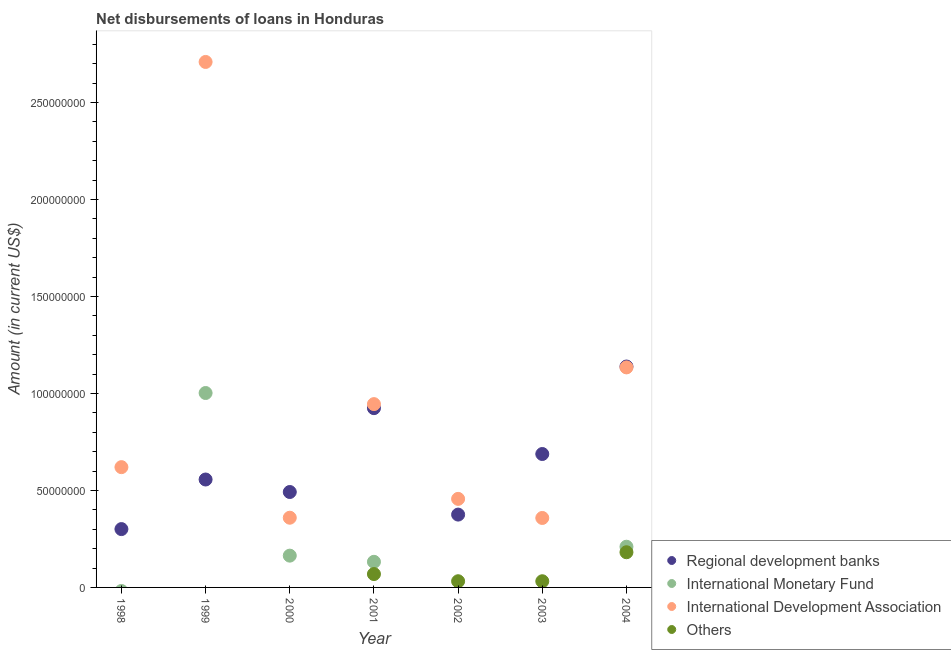Is the number of dotlines equal to the number of legend labels?
Give a very brief answer. No. What is the amount of loan disimbursed by other organisations in 2002?
Offer a very short reply. 3.20e+06. Across all years, what is the maximum amount of loan disimbursed by regional development banks?
Offer a terse response. 1.14e+08. In which year was the amount of loan disimbursed by regional development banks maximum?
Your answer should be very brief. 2004. What is the total amount of loan disimbursed by international monetary fund in the graph?
Your answer should be compact. 1.51e+08. What is the difference between the amount of loan disimbursed by international development association in 1998 and that in 2003?
Your answer should be very brief. 2.62e+07. What is the difference between the amount of loan disimbursed by international development association in 1999 and the amount of loan disimbursed by international monetary fund in 2002?
Keep it short and to the point. 2.71e+08. What is the average amount of loan disimbursed by international monetary fund per year?
Provide a succinct answer. 2.15e+07. In the year 2004, what is the difference between the amount of loan disimbursed by other organisations and amount of loan disimbursed by regional development banks?
Your answer should be very brief. -9.57e+07. In how many years, is the amount of loan disimbursed by other organisations greater than 160000000 US$?
Your answer should be compact. 0. What is the ratio of the amount of loan disimbursed by regional development banks in 1999 to that in 2003?
Provide a short and direct response. 0.81. Is the difference between the amount of loan disimbursed by other organisations in 2003 and 2004 greater than the difference between the amount of loan disimbursed by regional development banks in 2003 and 2004?
Provide a succinct answer. Yes. What is the difference between the highest and the second highest amount of loan disimbursed by international development association?
Make the answer very short. 1.57e+08. What is the difference between the highest and the lowest amount of loan disimbursed by other organisations?
Make the answer very short. 1.81e+07. In how many years, is the amount of loan disimbursed by other organisations greater than the average amount of loan disimbursed by other organisations taken over all years?
Ensure brevity in your answer.  2. Does the amount of loan disimbursed by other organisations monotonically increase over the years?
Give a very brief answer. No. Is the amount of loan disimbursed by other organisations strictly less than the amount of loan disimbursed by international development association over the years?
Your answer should be compact. Yes. How many dotlines are there?
Your answer should be very brief. 4. How many legend labels are there?
Make the answer very short. 4. What is the title of the graph?
Ensure brevity in your answer.  Net disbursements of loans in Honduras. Does "Japan" appear as one of the legend labels in the graph?
Make the answer very short. No. What is the label or title of the X-axis?
Offer a very short reply. Year. What is the label or title of the Y-axis?
Your answer should be compact. Amount (in current US$). What is the Amount (in current US$) in Regional development banks in 1998?
Ensure brevity in your answer.  3.01e+07. What is the Amount (in current US$) in International Development Association in 1998?
Ensure brevity in your answer.  6.20e+07. What is the Amount (in current US$) in Regional development banks in 1999?
Provide a succinct answer. 5.56e+07. What is the Amount (in current US$) in International Monetary Fund in 1999?
Your answer should be compact. 1.00e+08. What is the Amount (in current US$) in International Development Association in 1999?
Your answer should be compact. 2.71e+08. What is the Amount (in current US$) in Others in 1999?
Provide a short and direct response. 0. What is the Amount (in current US$) of Regional development banks in 2000?
Make the answer very short. 4.92e+07. What is the Amount (in current US$) of International Monetary Fund in 2000?
Provide a succinct answer. 1.64e+07. What is the Amount (in current US$) of International Development Association in 2000?
Offer a terse response. 3.59e+07. What is the Amount (in current US$) in Others in 2000?
Provide a short and direct response. 0. What is the Amount (in current US$) in Regional development banks in 2001?
Provide a succinct answer. 9.24e+07. What is the Amount (in current US$) of International Monetary Fund in 2001?
Your answer should be very brief. 1.32e+07. What is the Amount (in current US$) in International Development Association in 2001?
Your response must be concise. 9.45e+07. What is the Amount (in current US$) in Others in 2001?
Your response must be concise. 6.89e+06. What is the Amount (in current US$) of Regional development banks in 2002?
Offer a very short reply. 3.75e+07. What is the Amount (in current US$) in International Development Association in 2002?
Keep it short and to the point. 4.56e+07. What is the Amount (in current US$) in Others in 2002?
Offer a terse response. 3.20e+06. What is the Amount (in current US$) of Regional development banks in 2003?
Ensure brevity in your answer.  6.88e+07. What is the Amount (in current US$) in International Development Association in 2003?
Make the answer very short. 3.58e+07. What is the Amount (in current US$) in Others in 2003?
Your response must be concise. 3.18e+06. What is the Amount (in current US$) of Regional development banks in 2004?
Your answer should be compact. 1.14e+08. What is the Amount (in current US$) in International Monetary Fund in 2004?
Your answer should be very brief. 2.10e+07. What is the Amount (in current US$) in International Development Association in 2004?
Offer a terse response. 1.13e+08. What is the Amount (in current US$) in Others in 2004?
Give a very brief answer. 1.81e+07. Across all years, what is the maximum Amount (in current US$) in Regional development banks?
Give a very brief answer. 1.14e+08. Across all years, what is the maximum Amount (in current US$) of International Monetary Fund?
Your answer should be very brief. 1.00e+08. Across all years, what is the maximum Amount (in current US$) of International Development Association?
Your answer should be compact. 2.71e+08. Across all years, what is the maximum Amount (in current US$) of Others?
Offer a very short reply. 1.81e+07. Across all years, what is the minimum Amount (in current US$) in Regional development banks?
Give a very brief answer. 3.01e+07. Across all years, what is the minimum Amount (in current US$) in International Monetary Fund?
Offer a very short reply. 0. Across all years, what is the minimum Amount (in current US$) of International Development Association?
Offer a terse response. 3.58e+07. Across all years, what is the minimum Amount (in current US$) of Others?
Keep it short and to the point. 0. What is the total Amount (in current US$) of Regional development banks in the graph?
Your response must be concise. 4.47e+08. What is the total Amount (in current US$) in International Monetary Fund in the graph?
Make the answer very short. 1.51e+08. What is the total Amount (in current US$) in International Development Association in the graph?
Your answer should be very brief. 6.58e+08. What is the total Amount (in current US$) of Others in the graph?
Provide a short and direct response. 3.14e+07. What is the difference between the Amount (in current US$) of Regional development banks in 1998 and that in 1999?
Give a very brief answer. -2.56e+07. What is the difference between the Amount (in current US$) of International Development Association in 1998 and that in 1999?
Provide a succinct answer. -2.09e+08. What is the difference between the Amount (in current US$) in Regional development banks in 1998 and that in 2000?
Offer a terse response. -1.91e+07. What is the difference between the Amount (in current US$) in International Development Association in 1998 and that in 2000?
Provide a short and direct response. 2.61e+07. What is the difference between the Amount (in current US$) of Regional development banks in 1998 and that in 2001?
Ensure brevity in your answer.  -6.23e+07. What is the difference between the Amount (in current US$) in International Development Association in 1998 and that in 2001?
Keep it short and to the point. -3.25e+07. What is the difference between the Amount (in current US$) in Regional development banks in 1998 and that in 2002?
Provide a succinct answer. -7.47e+06. What is the difference between the Amount (in current US$) in International Development Association in 1998 and that in 2002?
Offer a terse response. 1.64e+07. What is the difference between the Amount (in current US$) of Regional development banks in 1998 and that in 2003?
Give a very brief answer. -3.87e+07. What is the difference between the Amount (in current US$) of International Development Association in 1998 and that in 2003?
Your answer should be very brief. 2.62e+07. What is the difference between the Amount (in current US$) in Regional development banks in 1998 and that in 2004?
Offer a terse response. -8.38e+07. What is the difference between the Amount (in current US$) in International Development Association in 1998 and that in 2004?
Provide a succinct answer. -5.14e+07. What is the difference between the Amount (in current US$) of Regional development banks in 1999 and that in 2000?
Ensure brevity in your answer.  6.44e+06. What is the difference between the Amount (in current US$) of International Monetary Fund in 1999 and that in 2000?
Provide a short and direct response. 8.38e+07. What is the difference between the Amount (in current US$) in International Development Association in 1999 and that in 2000?
Provide a short and direct response. 2.35e+08. What is the difference between the Amount (in current US$) in Regional development banks in 1999 and that in 2001?
Provide a short and direct response. -3.68e+07. What is the difference between the Amount (in current US$) in International Monetary Fund in 1999 and that in 2001?
Provide a short and direct response. 8.70e+07. What is the difference between the Amount (in current US$) of International Development Association in 1999 and that in 2001?
Your answer should be compact. 1.76e+08. What is the difference between the Amount (in current US$) in Regional development banks in 1999 and that in 2002?
Keep it short and to the point. 1.81e+07. What is the difference between the Amount (in current US$) of International Development Association in 1999 and that in 2002?
Provide a short and direct response. 2.25e+08. What is the difference between the Amount (in current US$) in Regional development banks in 1999 and that in 2003?
Provide a succinct answer. -1.31e+07. What is the difference between the Amount (in current US$) of International Development Association in 1999 and that in 2003?
Your response must be concise. 2.35e+08. What is the difference between the Amount (in current US$) in Regional development banks in 1999 and that in 2004?
Provide a short and direct response. -5.82e+07. What is the difference between the Amount (in current US$) in International Monetary Fund in 1999 and that in 2004?
Your answer should be compact. 7.92e+07. What is the difference between the Amount (in current US$) of International Development Association in 1999 and that in 2004?
Offer a terse response. 1.57e+08. What is the difference between the Amount (in current US$) in Regional development banks in 2000 and that in 2001?
Give a very brief answer. -4.32e+07. What is the difference between the Amount (in current US$) in International Monetary Fund in 2000 and that in 2001?
Your answer should be very brief. 3.18e+06. What is the difference between the Amount (in current US$) in International Development Association in 2000 and that in 2001?
Provide a succinct answer. -5.86e+07. What is the difference between the Amount (in current US$) in Regional development banks in 2000 and that in 2002?
Offer a very short reply. 1.16e+07. What is the difference between the Amount (in current US$) in International Development Association in 2000 and that in 2002?
Give a very brief answer. -9.72e+06. What is the difference between the Amount (in current US$) of Regional development banks in 2000 and that in 2003?
Provide a succinct answer. -1.96e+07. What is the difference between the Amount (in current US$) of International Development Association in 2000 and that in 2003?
Ensure brevity in your answer.  1.26e+05. What is the difference between the Amount (in current US$) of Regional development banks in 2000 and that in 2004?
Provide a succinct answer. -6.47e+07. What is the difference between the Amount (in current US$) in International Monetary Fund in 2000 and that in 2004?
Make the answer very short. -4.60e+06. What is the difference between the Amount (in current US$) in International Development Association in 2000 and that in 2004?
Give a very brief answer. -7.75e+07. What is the difference between the Amount (in current US$) of Regional development banks in 2001 and that in 2002?
Make the answer very short. 5.49e+07. What is the difference between the Amount (in current US$) in International Development Association in 2001 and that in 2002?
Your answer should be very brief. 4.88e+07. What is the difference between the Amount (in current US$) in Others in 2001 and that in 2002?
Offer a very short reply. 3.69e+06. What is the difference between the Amount (in current US$) of Regional development banks in 2001 and that in 2003?
Provide a succinct answer. 2.36e+07. What is the difference between the Amount (in current US$) of International Development Association in 2001 and that in 2003?
Offer a very short reply. 5.87e+07. What is the difference between the Amount (in current US$) in Others in 2001 and that in 2003?
Keep it short and to the point. 3.70e+06. What is the difference between the Amount (in current US$) in Regional development banks in 2001 and that in 2004?
Your answer should be compact. -2.15e+07. What is the difference between the Amount (in current US$) in International Monetary Fund in 2001 and that in 2004?
Offer a terse response. -7.78e+06. What is the difference between the Amount (in current US$) of International Development Association in 2001 and that in 2004?
Ensure brevity in your answer.  -1.89e+07. What is the difference between the Amount (in current US$) of Others in 2001 and that in 2004?
Provide a succinct answer. -1.12e+07. What is the difference between the Amount (in current US$) in Regional development banks in 2002 and that in 2003?
Ensure brevity in your answer.  -3.12e+07. What is the difference between the Amount (in current US$) in International Development Association in 2002 and that in 2003?
Ensure brevity in your answer.  9.84e+06. What is the difference between the Amount (in current US$) in Others in 2002 and that in 2003?
Offer a very short reply. 1.20e+04. What is the difference between the Amount (in current US$) in Regional development banks in 2002 and that in 2004?
Provide a short and direct response. -7.63e+07. What is the difference between the Amount (in current US$) in International Development Association in 2002 and that in 2004?
Offer a very short reply. -6.78e+07. What is the difference between the Amount (in current US$) of Others in 2002 and that in 2004?
Your answer should be compact. -1.49e+07. What is the difference between the Amount (in current US$) of Regional development banks in 2003 and that in 2004?
Provide a short and direct response. -4.51e+07. What is the difference between the Amount (in current US$) of International Development Association in 2003 and that in 2004?
Offer a very short reply. -7.76e+07. What is the difference between the Amount (in current US$) in Others in 2003 and that in 2004?
Make the answer very short. -1.49e+07. What is the difference between the Amount (in current US$) in Regional development banks in 1998 and the Amount (in current US$) in International Monetary Fund in 1999?
Your answer should be very brief. -7.01e+07. What is the difference between the Amount (in current US$) in Regional development banks in 1998 and the Amount (in current US$) in International Development Association in 1999?
Your answer should be very brief. -2.41e+08. What is the difference between the Amount (in current US$) of Regional development banks in 1998 and the Amount (in current US$) of International Monetary Fund in 2000?
Make the answer very short. 1.37e+07. What is the difference between the Amount (in current US$) in Regional development banks in 1998 and the Amount (in current US$) in International Development Association in 2000?
Your answer should be very brief. -5.86e+06. What is the difference between the Amount (in current US$) in Regional development banks in 1998 and the Amount (in current US$) in International Monetary Fund in 2001?
Ensure brevity in your answer.  1.69e+07. What is the difference between the Amount (in current US$) in Regional development banks in 1998 and the Amount (in current US$) in International Development Association in 2001?
Your answer should be very brief. -6.44e+07. What is the difference between the Amount (in current US$) in Regional development banks in 1998 and the Amount (in current US$) in Others in 2001?
Keep it short and to the point. 2.32e+07. What is the difference between the Amount (in current US$) in International Development Association in 1998 and the Amount (in current US$) in Others in 2001?
Make the answer very short. 5.51e+07. What is the difference between the Amount (in current US$) in Regional development banks in 1998 and the Amount (in current US$) in International Development Association in 2002?
Your response must be concise. -1.56e+07. What is the difference between the Amount (in current US$) in Regional development banks in 1998 and the Amount (in current US$) in Others in 2002?
Ensure brevity in your answer.  2.69e+07. What is the difference between the Amount (in current US$) in International Development Association in 1998 and the Amount (in current US$) in Others in 2002?
Provide a short and direct response. 5.88e+07. What is the difference between the Amount (in current US$) in Regional development banks in 1998 and the Amount (in current US$) in International Development Association in 2003?
Keep it short and to the point. -5.73e+06. What is the difference between the Amount (in current US$) in Regional development banks in 1998 and the Amount (in current US$) in Others in 2003?
Give a very brief answer. 2.69e+07. What is the difference between the Amount (in current US$) in International Development Association in 1998 and the Amount (in current US$) in Others in 2003?
Keep it short and to the point. 5.88e+07. What is the difference between the Amount (in current US$) in Regional development banks in 1998 and the Amount (in current US$) in International Monetary Fund in 2004?
Your answer should be very brief. 9.09e+06. What is the difference between the Amount (in current US$) in Regional development banks in 1998 and the Amount (in current US$) in International Development Association in 2004?
Provide a succinct answer. -8.33e+07. What is the difference between the Amount (in current US$) of Regional development banks in 1998 and the Amount (in current US$) of Others in 2004?
Give a very brief answer. 1.19e+07. What is the difference between the Amount (in current US$) in International Development Association in 1998 and the Amount (in current US$) in Others in 2004?
Offer a terse response. 4.39e+07. What is the difference between the Amount (in current US$) of Regional development banks in 1999 and the Amount (in current US$) of International Monetary Fund in 2000?
Give a very brief answer. 3.92e+07. What is the difference between the Amount (in current US$) in Regional development banks in 1999 and the Amount (in current US$) in International Development Association in 2000?
Ensure brevity in your answer.  1.97e+07. What is the difference between the Amount (in current US$) of International Monetary Fund in 1999 and the Amount (in current US$) of International Development Association in 2000?
Keep it short and to the point. 6.43e+07. What is the difference between the Amount (in current US$) in Regional development banks in 1999 and the Amount (in current US$) in International Monetary Fund in 2001?
Provide a succinct answer. 4.24e+07. What is the difference between the Amount (in current US$) in Regional development banks in 1999 and the Amount (in current US$) in International Development Association in 2001?
Your response must be concise. -3.89e+07. What is the difference between the Amount (in current US$) of Regional development banks in 1999 and the Amount (in current US$) of Others in 2001?
Make the answer very short. 4.87e+07. What is the difference between the Amount (in current US$) in International Monetary Fund in 1999 and the Amount (in current US$) in International Development Association in 2001?
Keep it short and to the point. 5.72e+06. What is the difference between the Amount (in current US$) in International Monetary Fund in 1999 and the Amount (in current US$) in Others in 2001?
Your answer should be very brief. 9.33e+07. What is the difference between the Amount (in current US$) in International Development Association in 1999 and the Amount (in current US$) in Others in 2001?
Provide a short and direct response. 2.64e+08. What is the difference between the Amount (in current US$) in Regional development banks in 1999 and the Amount (in current US$) in International Development Association in 2002?
Give a very brief answer. 9.98e+06. What is the difference between the Amount (in current US$) of Regional development banks in 1999 and the Amount (in current US$) of Others in 2002?
Your answer should be compact. 5.24e+07. What is the difference between the Amount (in current US$) in International Monetary Fund in 1999 and the Amount (in current US$) in International Development Association in 2002?
Offer a very short reply. 5.46e+07. What is the difference between the Amount (in current US$) in International Monetary Fund in 1999 and the Amount (in current US$) in Others in 2002?
Make the answer very short. 9.70e+07. What is the difference between the Amount (in current US$) in International Development Association in 1999 and the Amount (in current US$) in Others in 2002?
Provide a succinct answer. 2.68e+08. What is the difference between the Amount (in current US$) of Regional development banks in 1999 and the Amount (in current US$) of International Development Association in 2003?
Provide a short and direct response. 1.98e+07. What is the difference between the Amount (in current US$) of Regional development banks in 1999 and the Amount (in current US$) of Others in 2003?
Your answer should be compact. 5.24e+07. What is the difference between the Amount (in current US$) in International Monetary Fund in 1999 and the Amount (in current US$) in International Development Association in 2003?
Give a very brief answer. 6.44e+07. What is the difference between the Amount (in current US$) of International Monetary Fund in 1999 and the Amount (in current US$) of Others in 2003?
Give a very brief answer. 9.70e+07. What is the difference between the Amount (in current US$) in International Development Association in 1999 and the Amount (in current US$) in Others in 2003?
Provide a short and direct response. 2.68e+08. What is the difference between the Amount (in current US$) in Regional development banks in 1999 and the Amount (in current US$) in International Monetary Fund in 2004?
Your answer should be very brief. 3.46e+07. What is the difference between the Amount (in current US$) in Regional development banks in 1999 and the Amount (in current US$) in International Development Association in 2004?
Make the answer very short. -5.78e+07. What is the difference between the Amount (in current US$) in Regional development banks in 1999 and the Amount (in current US$) in Others in 2004?
Make the answer very short. 3.75e+07. What is the difference between the Amount (in current US$) in International Monetary Fund in 1999 and the Amount (in current US$) in International Development Association in 2004?
Give a very brief answer. -1.32e+07. What is the difference between the Amount (in current US$) of International Monetary Fund in 1999 and the Amount (in current US$) of Others in 2004?
Give a very brief answer. 8.21e+07. What is the difference between the Amount (in current US$) of International Development Association in 1999 and the Amount (in current US$) of Others in 2004?
Your response must be concise. 2.53e+08. What is the difference between the Amount (in current US$) of Regional development banks in 2000 and the Amount (in current US$) of International Monetary Fund in 2001?
Your response must be concise. 3.60e+07. What is the difference between the Amount (in current US$) in Regional development banks in 2000 and the Amount (in current US$) in International Development Association in 2001?
Offer a very short reply. -4.53e+07. What is the difference between the Amount (in current US$) of Regional development banks in 2000 and the Amount (in current US$) of Others in 2001?
Provide a succinct answer. 4.23e+07. What is the difference between the Amount (in current US$) of International Monetary Fund in 2000 and the Amount (in current US$) of International Development Association in 2001?
Your answer should be very brief. -7.81e+07. What is the difference between the Amount (in current US$) of International Monetary Fund in 2000 and the Amount (in current US$) of Others in 2001?
Provide a short and direct response. 9.49e+06. What is the difference between the Amount (in current US$) in International Development Association in 2000 and the Amount (in current US$) in Others in 2001?
Your answer should be very brief. 2.90e+07. What is the difference between the Amount (in current US$) in Regional development banks in 2000 and the Amount (in current US$) in International Development Association in 2002?
Provide a short and direct response. 3.54e+06. What is the difference between the Amount (in current US$) of Regional development banks in 2000 and the Amount (in current US$) of Others in 2002?
Your response must be concise. 4.60e+07. What is the difference between the Amount (in current US$) of International Monetary Fund in 2000 and the Amount (in current US$) of International Development Association in 2002?
Give a very brief answer. -2.93e+07. What is the difference between the Amount (in current US$) in International Monetary Fund in 2000 and the Amount (in current US$) in Others in 2002?
Your response must be concise. 1.32e+07. What is the difference between the Amount (in current US$) of International Development Association in 2000 and the Amount (in current US$) of Others in 2002?
Offer a terse response. 3.27e+07. What is the difference between the Amount (in current US$) in Regional development banks in 2000 and the Amount (in current US$) in International Development Association in 2003?
Provide a succinct answer. 1.34e+07. What is the difference between the Amount (in current US$) of Regional development banks in 2000 and the Amount (in current US$) of Others in 2003?
Your answer should be very brief. 4.60e+07. What is the difference between the Amount (in current US$) of International Monetary Fund in 2000 and the Amount (in current US$) of International Development Association in 2003?
Provide a succinct answer. -1.94e+07. What is the difference between the Amount (in current US$) of International Monetary Fund in 2000 and the Amount (in current US$) of Others in 2003?
Ensure brevity in your answer.  1.32e+07. What is the difference between the Amount (in current US$) in International Development Association in 2000 and the Amount (in current US$) in Others in 2003?
Your answer should be very brief. 3.27e+07. What is the difference between the Amount (in current US$) in Regional development banks in 2000 and the Amount (in current US$) in International Monetary Fund in 2004?
Your answer should be compact. 2.82e+07. What is the difference between the Amount (in current US$) in Regional development banks in 2000 and the Amount (in current US$) in International Development Association in 2004?
Make the answer very short. -6.42e+07. What is the difference between the Amount (in current US$) of Regional development banks in 2000 and the Amount (in current US$) of Others in 2004?
Your answer should be very brief. 3.11e+07. What is the difference between the Amount (in current US$) in International Monetary Fund in 2000 and the Amount (in current US$) in International Development Association in 2004?
Provide a short and direct response. -9.70e+07. What is the difference between the Amount (in current US$) of International Monetary Fund in 2000 and the Amount (in current US$) of Others in 2004?
Make the answer very short. -1.75e+06. What is the difference between the Amount (in current US$) of International Development Association in 2000 and the Amount (in current US$) of Others in 2004?
Make the answer very short. 1.78e+07. What is the difference between the Amount (in current US$) of Regional development banks in 2001 and the Amount (in current US$) of International Development Association in 2002?
Provide a short and direct response. 4.68e+07. What is the difference between the Amount (in current US$) in Regional development banks in 2001 and the Amount (in current US$) in Others in 2002?
Keep it short and to the point. 8.92e+07. What is the difference between the Amount (in current US$) of International Monetary Fund in 2001 and the Amount (in current US$) of International Development Association in 2002?
Make the answer very short. -3.24e+07. What is the difference between the Amount (in current US$) in International Monetary Fund in 2001 and the Amount (in current US$) in Others in 2002?
Offer a terse response. 1.00e+07. What is the difference between the Amount (in current US$) of International Development Association in 2001 and the Amount (in current US$) of Others in 2002?
Your answer should be compact. 9.13e+07. What is the difference between the Amount (in current US$) of Regional development banks in 2001 and the Amount (in current US$) of International Development Association in 2003?
Provide a succinct answer. 5.66e+07. What is the difference between the Amount (in current US$) of Regional development banks in 2001 and the Amount (in current US$) of Others in 2003?
Your response must be concise. 8.92e+07. What is the difference between the Amount (in current US$) of International Monetary Fund in 2001 and the Amount (in current US$) of International Development Association in 2003?
Offer a very short reply. -2.26e+07. What is the difference between the Amount (in current US$) in International Monetary Fund in 2001 and the Amount (in current US$) in Others in 2003?
Keep it short and to the point. 1.00e+07. What is the difference between the Amount (in current US$) in International Development Association in 2001 and the Amount (in current US$) in Others in 2003?
Provide a succinct answer. 9.13e+07. What is the difference between the Amount (in current US$) of Regional development banks in 2001 and the Amount (in current US$) of International Monetary Fund in 2004?
Your answer should be compact. 7.14e+07. What is the difference between the Amount (in current US$) of Regional development banks in 2001 and the Amount (in current US$) of International Development Association in 2004?
Offer a very short reply. -2.10e+07. What is the difference between the Amount (in current US$) in Regional development banks in 2001 and the Amount (in current US$) in Others in 2004?
Your response must be concise. 7.43e+07. What is the difference between the Amount (in current US$) in International Monetary Fund in 2001 and the Amount (in current US$) in International Development Association in 2004?
Your answer should be very brief. -1.00e+08. What is the difference between the Amount (in current US$) in International Monetary Fund in 2001 and the Amount (in current US$) in Others in 2004?
Ensure brevity in your answer.  -4.94e+06. What is the difference between the Amount (in current US$) in International Development Association in 2001 and the Amount (in current US$) in Others in 2004?
Provide a short and direct response. 7.64e+07. What is the difference between the Amount (in current US$) in Regional development banks in 2002 and the Amount (in current US$) in International Development Association in 2003?
Your answer should be very brief. 1.74e+06. What is the difference between the Amount (in current US$) in Regional development banks in 2002 and the Amount (in current US$) in Others in 2003?
Offer a terse response. 3.44e+07. What is the difference between the Amount (in current US$) of International Development Association in 2002 and the Amount (in current US$) of Others in 2003?
Provide a succinct answer. 4.25e+07. What is the difference between the Amount (in current US$) in Regional development banks in 2002 and the Amount (in current US$) in International Monetary Fund in 2004?
Provide a succinct answer. 1.66e+07. What is the difference between the Amount (in current US$) of Regional development banks in 2002 and the Amount (in current US$) of International Development Association in 2004?
Give a very brief answer. -7.59e+07. What is the difference between the Amount (in current US$) of Regional development banks in 2002 and the Amount (in current US$) of Others in 2004?
Provide a succinct answer. 1.94e+07. What is the difference between the Amount (in current US$) in International Development Association in 2002 and the Amount (in current US$) in Others in 2004?
Provide a succinct answer. 2.75e+07. What is the difference between the Amount (in current US$) of Regional development banks in 2003 and the Amount (in current US$) of International Monetary Fund in 2004?
Your response must be concise. 4.78e+07. What is the difference between the Amount (in current US$) in Regional development banks in 2003 and the Amount (in current US$) in International Development Association in 2004?
Offer a very short reply. -4.46e+07. What is the difference between the Amount (in current US$) of Regional development banks in 2003 and the Amount (in current US$) of Others in 2004?
Make the answer very short. 5.06e+07. What is the difference between the Amount (in current US$) of International Development Association in 2003 and the Amount (in current US$) of Others in 2004?
Make the answer very short. 1.77e+07. What is the average Amount (in current US$) of Regional development banks per year?
Your answer should be compact. 6.39e+07. What is the average Amount (in current US$) in International Monetary Fund per year?
Give a very brief answer. 2.15e+07. What is the average Amount (in current US$) in International Development Association per year?
Offer a terse response. 9.40e+07. What is the average Amount (in current US$) in Others per year?
Ensure brevity in your answer.  4.49e+06. In the year 1998, what is the difference between the Amount (in current US$) in Regional development banks and Amount (in current US$) in International Development Association?
Keep it short and to the point. -3.19e+07. In the year 1999, what is the difference between the Amount (in current US$) of Regional development banks and Amount (in current US$) of International Monetary Fund?
Offer a terse response. -4.46e+07. In the year 1999, what is the difference between the Amount (in current US$) in Regional development banks and Amount (in current US$) in International Development Association?
Your response must be concise. -2.15e+08. In the year 1999, what is the difference between the Amount (in current US$) in International Monetary Fund and Amount (in current US$) in International Development Association?
Your answer should be very brief. -1.71e+08. In the year 2000, what is the difference between the Amount (in current US$) of Regional development banks and Amount (in current US$) of International Monetary Fund?
Provide a succinct answer. 3.28e+07. In the year 2000, what is the difference between the Amount (in current US$) of Regional development banks and Amount (in current US$) of International Development Association?
Your answer should be very brief. 1.33e+07. In the year 2000, what is the difference between the Amount (in current US$) of International Monetary Fund and Amount (in current US$) of International Development Association?
Give a very brief answer. -1.95e+07. In the year 2001, what is the difference between the Amount (in current US$) of Regional development banks and Amount (in current US$) of International Monetary Fund?
Offer a terse response. 7.92e+07. In the year 2001, what is the difference between the Amount (in current US$) of Regional development banks and Amount (in current US$) of International Development Association?
Your answer should be very brief. -2.08e+06. In the year 2001, what is the difference between the Amount (in current US$) of Regional development banks and Amount (in current US$) of Others?
Give a very brief answer. 8.55e+07. In the year 2001, what is the difference between the Amount (in current US$) in International Monetary Fund and Amount (in current US$) in International Development Association?
Make the answer very short. -8.13e+07. In the year 2001, what is the difference between the Amount (in current US$) of International Monetary Fund and Amount (in current US$) of Others?
Your answer should be very brief. 6.31e+06. In the year 2001, what is the difference between the Amount (in current US$) of International Development Association and Amount (in current US$) of Others?
Give a very brief answer. 8.76e+07. In the year 2002, what is the difference between the Amount (in current US$) of Regional development banks and Amount (in current US$) of International Development Association?
Offer a very short reply. -8.10e+06. In the year 2002, what is the difference between the Amount (in current US$) in Regional development banks and Amount (in current US$) in Others?
Offer a terse response. 3.43e+07. In the year 2002, what is the difference between the Amount (in current US$) of International Development Association and Amount (in current US$) of Others?
Offer a terse response. 4.25e+07. In the year 2003, what is the difference between the Amount (in current US$) of Regional development banks and Amount (in current US$) of International Development Association?
Ensure brevity in your answer.  3.30e+07. In the year 2003, what is the difference between the Amount (in current US$) in Regional development banks and Amount (in current US$) in Others?
Make the answer very short. 6.56e+07. In the year 2003, what is the difference between the Amount (in current US$) in International Development Association and Amount (in current US$) in Others?
Provide a short and direct response. 3.26e+07. In the year 2004, what is the difference between the Amount (in current US$) in Regional development banks and Amount (in current US$) in International Monetary Fund?
Offer a terse response. 9.29e+07. In the year 2004, what is the difference between the Amount (in current US$) of Regional development banks and Amount (in current US$) of International Development Association?
Your answer should be compact. 4.52e+05. In the year 2004, what is the difference between the Amount (in current US$) in Regional development banks and Amount (in current US$) in Others?
Provide a short and direct response. 9.57e+07. In the year 2004, what is the difference between the Amount (in current US$) in International Monetary Fund and Amount (in current US$) in International Development Association?
Your response must be concise. -9.24e+07. In the year 2004, what is the difference between the Amount (in current US$) in International Monetary Fund and Amount (in current US$) in Others?
Your response must be concise. 2.85e+06. In the year 2004, what is the difference between the Amount (in current US$) in International Development Association and Amount (in current US$) in Others?
Keep it short and to the point. 9.53e+07. What is the ratio of the Amount (in current US$) in Regional development banks in 1998 to that in 1999?
Keep it short and to the point. 0.54. What is the ratio of the Amount (in current US$) of International Development Association in 1998 to that in 1999?
Offer a very short reply. 0.23. What is the ratio of the Amount (in current US$) of Regional development banks in 1998 to that in 2000?
Ensure brevity in your answer.  0.61. What is the ratio of the Amount (in current US$) of International Development Association in 1998 to that in 2000?
Give a very brief answer. 1.73. What is the ratio of the Amount (in current US$) of Regional development banks in 1998 to that in 2001?
Keep it short and to the point. 0.33. What is the ratio of the Amount (in current US$) in International Development Association in 1998 to that in 2001?
Provide a succinct answer. 0.66. What is the ratio of the Amount (in current US$) in Regional development banks in 1998 to that in 2002?
Offer a terse response. 0.8. What is the ratio of the Amount (in current US$) of International Development Association in 1998 to that in 2002?
Ensure brevity in your answer.  1.36. What is the ratio of the Amount (in current US$) of Regional development banks in 1998 to that in 2003?
Your answer should be very brief. 0.44. What is the ratio of the Amount (in current US$) in International Development Association in 1998 to that in 2003?
Ensure brevity in your answer.  1.73. What is the ratio of the Amount (in current US$) in Regional development banks in 1998 to that in 2004?
Keep it short and to the point. 0.26. What is the ratio of the Amount (in current US$) of International Development Association in 1998 to that in 2004?
Keep it short and to the point. 0.55. What is the ratio of the Amount (in current US$) of Regional development banks in 1999 to that in 2000?
Provide a succinct answer. 1.13. What is the ratio of the Amount (in current US$) in International Monetary Fund in 1999 to that in 2000?
Give a very brief answer. 6.12. What is the ratio of the Amount (in current US$) of International Development Association in 1999 to that in 2000?
Your response must be concise. 7.54. What is the ratio of the Amount (in current US$) of Regional development banks in 1999 to that in 2001?
Ensure brevity in your answer.  0.6. What is the ratio of the Amount (in current US$) in International Monetary Fund in 1999 to that in 2001?
Keep it short and to the point. 7.59. What is the ratio of the Amount (in current US$) of International Development Association in 1999 to that in 2001?
Give a very brief answer. 2.87. What is the ratio of the Amount (in current US$) of Regional development banks in 1999 to that in 2002?
Make the answer very short. 1.48. What is the ratio of the Amount (in current US$) of International Development Association in 1999 to that in 2002?
Your answer should be very brief. 5.93. What is the ratio of the Amount (in current US$) in Regional development banks in 1999 to that in 2003?
Provide a short and direct response. 0.81. What is the ratio of the Amount (in current US$) of International Development Association in 1999 to that in 2003?
Ensure brevity in your answer.  7.57. What is the ratio of the Amount (in current US$) in Regional development banks in 1999 to that in 2004?
Give a very brief answer. 0.49. What is the ratio of the Amount (in current US$) in International Monetary Fund in 1999 to that in 2004?
Provide a short and direct response. 4.78. What is the ratio of the Amount (in current US$) in International Development Association in 1999 to that in 2004?
Provide a short and direct response. 2.39. What is the ratio of the Amount (in current US$) in Regional development banks in 2000 to that in 2001?
Your response must be concise. 0.53. What is the ratio of the Amount (in current US$) of International Monetary Fund in 2000 to that in 2001?
Offer a terse response. 1.24. What is the ratio of the Amount (in current US$) of International Development Association in 2000 to that in 2001?
Your response must be concise. 0.38. What is the ratio of the Amount (in current US$) of Regional development banks in 2000 to that in 2002?
Offer a very short reply. 1.31. What is the ratio of the Amount (in current US$) in International Development Association in 2000 to that in 2002?
Your answer should be compact. 0.79. What is the ratio of the Amount (in current US$) in Regional development banks in 2000 to that in 2003?
Keep it short and to the point. 0.72. What is the ratio of the Amount (in current US$) in International Development Association in 2000 to that in 2003?
Your answer should be compact. 1. What is the ratio of the Amount (in current US$) of Regional development banks in 2000 to that in 2004?
Provide a succinct answer. 0.43. What is the ratio of the Amount (in current US$) of International Monetary Fund in 2000 to that in 2004?
Your answer should be compact. 0.78. What is the ratio of the Amount (in current US$) in International Development Association in 2000 to that in 2004?
Your answer should be very brief. 0.32. What is the ratio of the Amount (in current US$) in Regional development banks in 2001 to that in 2002?
Your answer should be compact. 2.46. What is the ratio of the Amount (in current US$) of International Development Association in 2001 to that in 2002?
Provide a succinct answer. 2.07. What is the ratio of the Amount (in current US$) in Others in 2001 to that in 2002?
Keep it short and to the point. 2.16. What is the ratio of the Amount (in current US$) in Regional development banks in 2001 to that in 2003?
Offer a very short reply. 1.34. What is the ratio of the Amount (in current US$) in International Development Association in 2001 to that in 2003?
Ensure brevity in your answer.  2.64. What is the ratio of the Amount (in current US$) in Others in 2001 to that in 2003?
Your response must be concise. 2.16. What is the ratio of the Amount (in current US$) in Regional development banks in 2001 to that in 2004?
Give a very brief answer. 0.81. What is the ratio of the Amount (in current US$) of International Monetary Fund in 2001 to that in 2004?
Offer a terse response. 0.63. What is the ratio of the Amount (in current US$) of International Development Association in 2001 to that in 2004?
Keep it short and to the point. 0.83. What is the ratio of the Amount (in current US$) of Others in 2001 to that in 2004?
Give a very brief answer. 0.38. What is the ratio of the Amount (in current US$) in Regional development banks in 2002 to that in 2003?
Your answer should be compact. 0.55. What is the ratio of the Amount (in current US$) in International Development Association in 2002 to that in 2003?
Your answer should be compact. 1.27. What is the ratio of the Amount (in current US$) in Regional development banks in 2002 to that in 2004?
Provide a short and direct response. 0.33. What is the ratio of the Amount (in current US$) in International Development Association in 2002 to that in 2004?
Your response must be concise. 0.4. What is the ratio of the Amount (in current US$) of Others in 2002 to that in 2004?
Ensure brevity in your answer.  0.18. What is the ratio of the Amount (in current US$) in Regional development banks in 2003 to that in 2004?
Provide a short and direct response. 0.6. What is the ratio of the Amount (in current US$) in International Development Association in 2003 to that in 2004?
Provide a short and direct response. 0.32. What is the ratio of the Amount (in current US$) in Others in 2003 to that in 2004?
Provide a succinct answer. 0.18. What is the difference between the highest and the second highest Amount (in current US$) of Regional development banks?
Your response must be concise. 2.15e+07. What is the difference between the highest and the second highest Amount (in current US$) of International Monetary Fund?
Your response must be concise. 7.92e+07. What is the difference between the highest and the second highest Amount (in current US$) in International Development Association?
Offer a very short reply. 1.57e+08. What is the difference between the highest and the second highest Amount (in current US$) in Others?
Provide a short and direct response. 1.12e+07. What is the difference between the highest and the lowest Amount (in current US$) in Regional development banks?
Offer a very short reply. 8.38e+07. What is the difference between the highest and the lowest Amount (in current US$) of International Monetary Fund?
Provide a succinct answer. 1.00e+08. What is the difference between the highest and the lowest Amount (in current US$) of International Development Association?
Your response must be concise. 2.35e+08. What is the difference between the highest and the lowest Amount (in current US$) in Others?
Keep it short and to the point. 1.81e+07. 